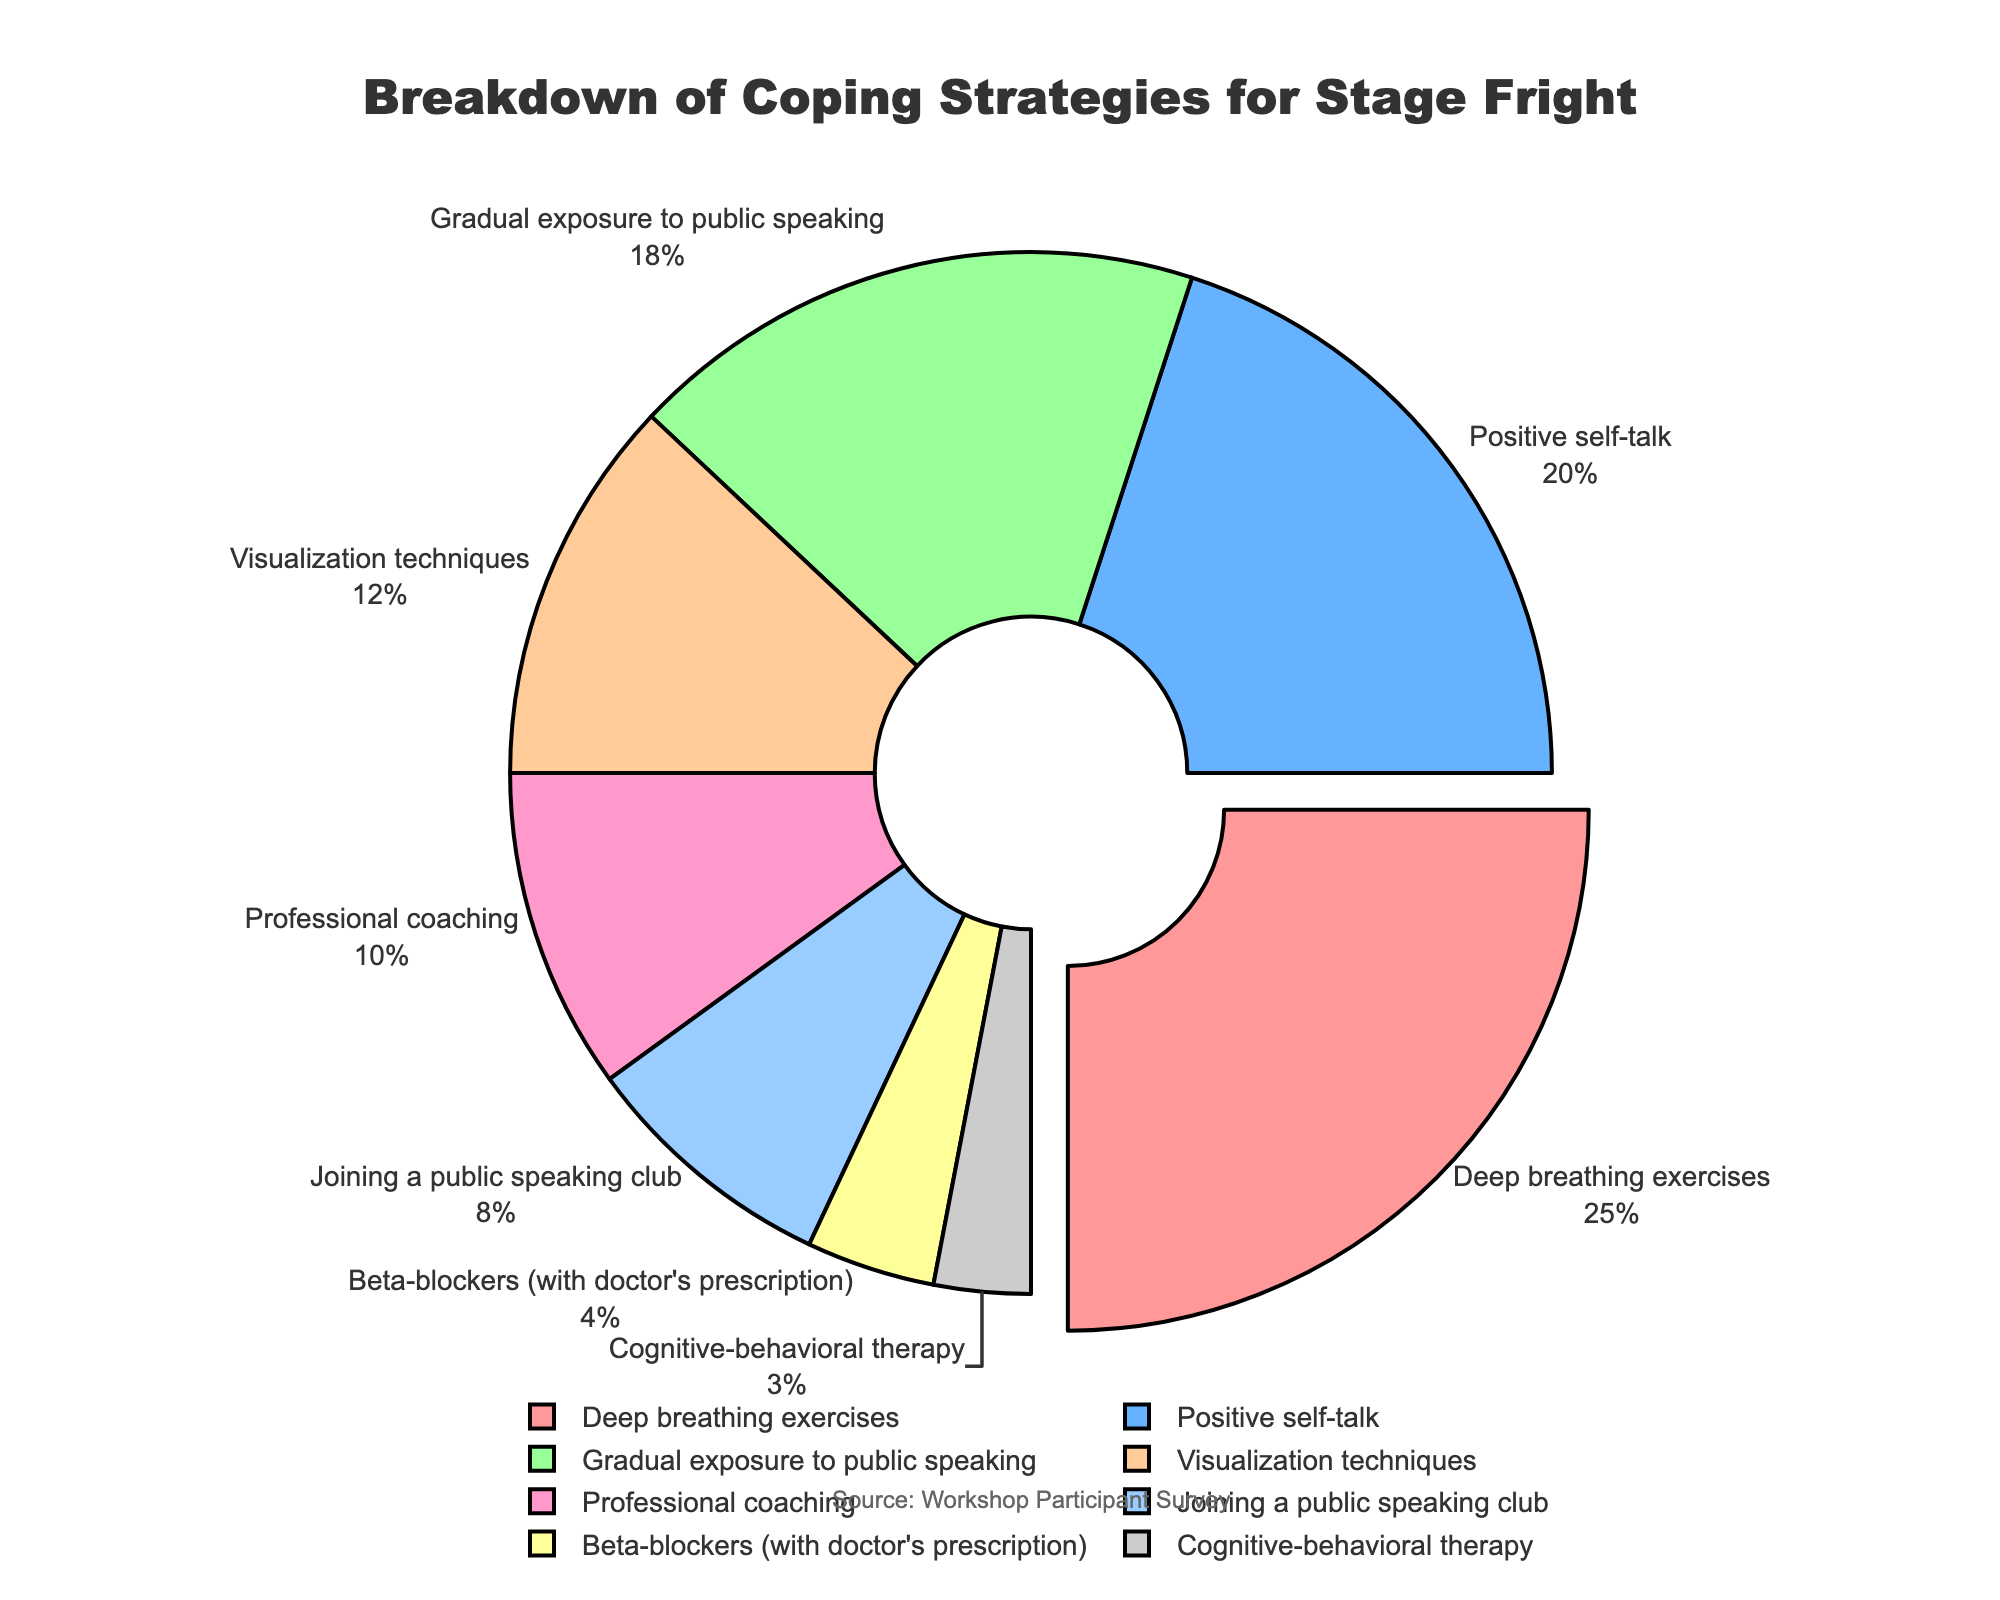What's the most used coping strategy for overcoming stage fright? The pie chart clearly shows that "Deep breathing exercises" has the largest section, making it the most used strategy.
Answer: Deep breathing exercises Which coping strategy is used more: Visualization techniques or Professional coaching? By comparing the percentages, we see that Visualization techniques is at 12% while Professional coaching is at 10%, thus Visualization techniques is used more.
Answer: Visualization techniques What is the combined percentage of people using Beta-blockers and Cognitive-behavioral therapy? Sum the percentages of Beta-blockers (4%) and Cognitive-behavioral therapy (3%): 4 + 3 = 7%.
Answer: 7% Between Positive self-talk and Joining a public speaking club, which strategy is less commonly used? Positive self-talk is used by 20% of people, whereas Joining a public speaking club is used by 8%. Therefore, Joining a public speaking club is less commonly used.
Answer: Joining a public speaking club What proportion of the pie chart is taken up by Visualization techniques and Gradual exposure to public speaking combined? Sum the percentages of Visualization techniques (12%) and Gradual exposure to public speaking (18%): 12 + 18 = 30%.
Answer: 30% How many strategies are utilized by more than 10% of the participants? From the pie chart, the strategies utilized by more than 10% of participants are: Deep breathing exercises (25%), Positive self-talk (20%), Gradual exposure to public speaking (18%), and Visualization techniques (12%). That's a total of 4 strategies.
Answer: 4 Which strategy takes up the smallest proportion of the pie chart? The smallest slice of the pie chart is labeled Cognitive-behavioral therapy at 3%.
Answer: Cognitive-behavioral therapy How much more common is Positive self-talk compared to Beta-blockers? Subtract the percentage of Beta-blockers (4%) from Positive self-talk (20%): 20 - 4 = 16%.
Answer: 16% What is the combined percentage of the three least common strategies? The three least common strategies are Beta-blockers (4%), Cognitive-behavioral therapy (3%), and Joining a public speaking club (8%). Their combined percentage is 4 + 3 + 8 = 15%.
Answer: 15% Which strategy has the second largest section in the pie chart? After Deep breathing exercises, which takes up the largest section, Positive self-talk is the next largest at 20%.
Answer: Positive self-talk 